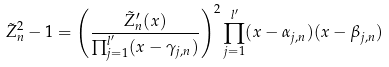Convert formula to latex. <formula><loc_0><loc_0><loc_500><loc_500>\tilde { Z } _ { n } ^ { 2 } - 1 = \left ( \frac { \tilde { Z } _ { n } ^ { \prime } ( x ) } { \prod _ { j = 1 } ^ { l ^ { \prime } } ( x - \gamma _ { j , n } ) } \right ) ^ { 2 } \prod _ { j = 1 } ^ { l ^ { \prime } } ( x - \alpha _ { j , n } ) ( x - \beta _ { j , n } )</formula> 